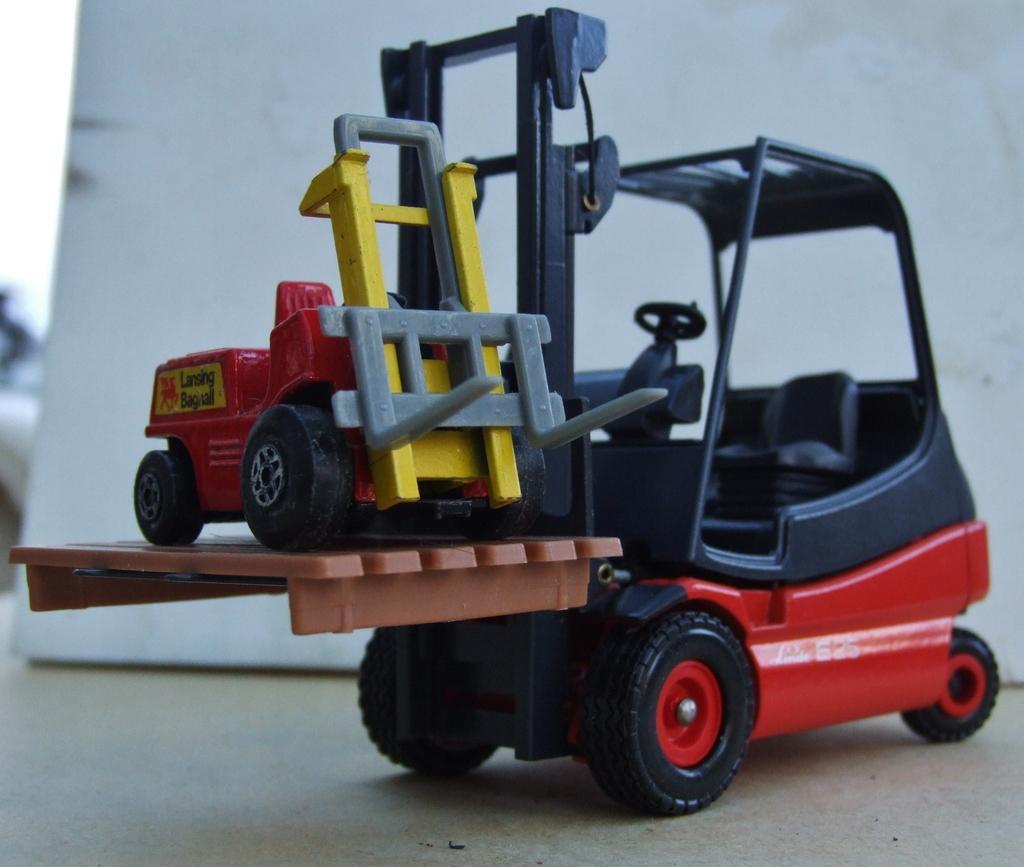Describe this image in one or two sentences. In this image I can see two toys vehicles. I can see color of these vehicles are red, yellow and black. In the background I can see the white colour wall and I can also see this image is little bit blurry. 